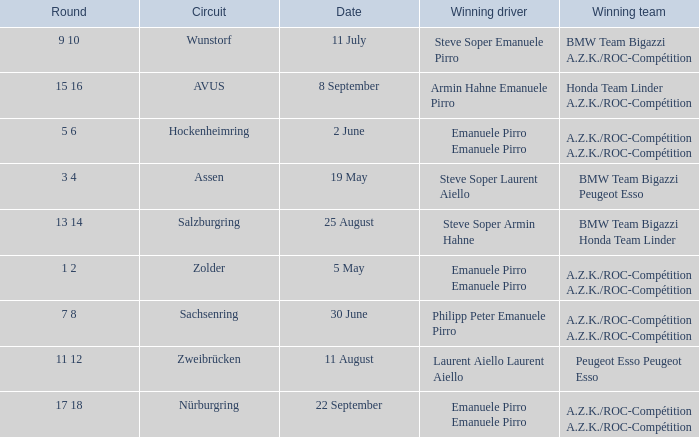What is the date of the zolder circuit, which had a.z.k./roc-compétition a.z.k./roc-compétition as the winning team? 5 May. Would you mind parsing the complete table? {'header': ['Round', 'Circuit', 'Date', 'Winning driver', 'Winning team'], 'rows': [['9 10', 'Wunstorf', '11 July', 'Steve Soper Emanuele Pirro', 'BMW Team Bigazzi A.Z.K./ROC-Compétition'], ['15 16', 'AVUS', '8 September', 'Armin Hahne Emanuele Pirro', 'Honda Team Linder A.Z.K./ROC-Compétition'], ['5 6', 'Hockenheimring', '2 June', 'Emanuele Pirro Emanuele Pirro', 'A.Z.K./ROC-Compétition A.Z.K./ROC-Compétition'], ['3 4', 'Assen', '19 May', 'Steve Soper Laurent Aiello', 'BMW Team Bigazzi Peugeot Esso'], ['13 14', 'Salzburgring', '25 August', 'Steve Soper Armin Hahne', 'BMW Team Bigazzi Honda Team Linder'], ['1 2', 'Zolder', '5 May', 'Emanuele Pirro Emanuele Pirro', 'A.Z.K./ROC-Compétition A.Z.K./ROC-Compétition'], ['7 8', 'Sachsenring', '30 June', 'Philipp Peter Emanuele Pirro', 'A.Z.K./ROC-Compétition A.Z.K./ROC-Compétition'], ['11 12', 'Zweibrücken', '11 August', 'Laurent Aiello Laurent Aiello', 'Peugeot Esso Peugeot Esso'], ['17 18', 'Nürburgring', '22 September', 'Emanuele Pirro Emanuele Pirro', 'A.Z.K./ROC-Compétition A.Z.K./ROC-Compétition']]} 